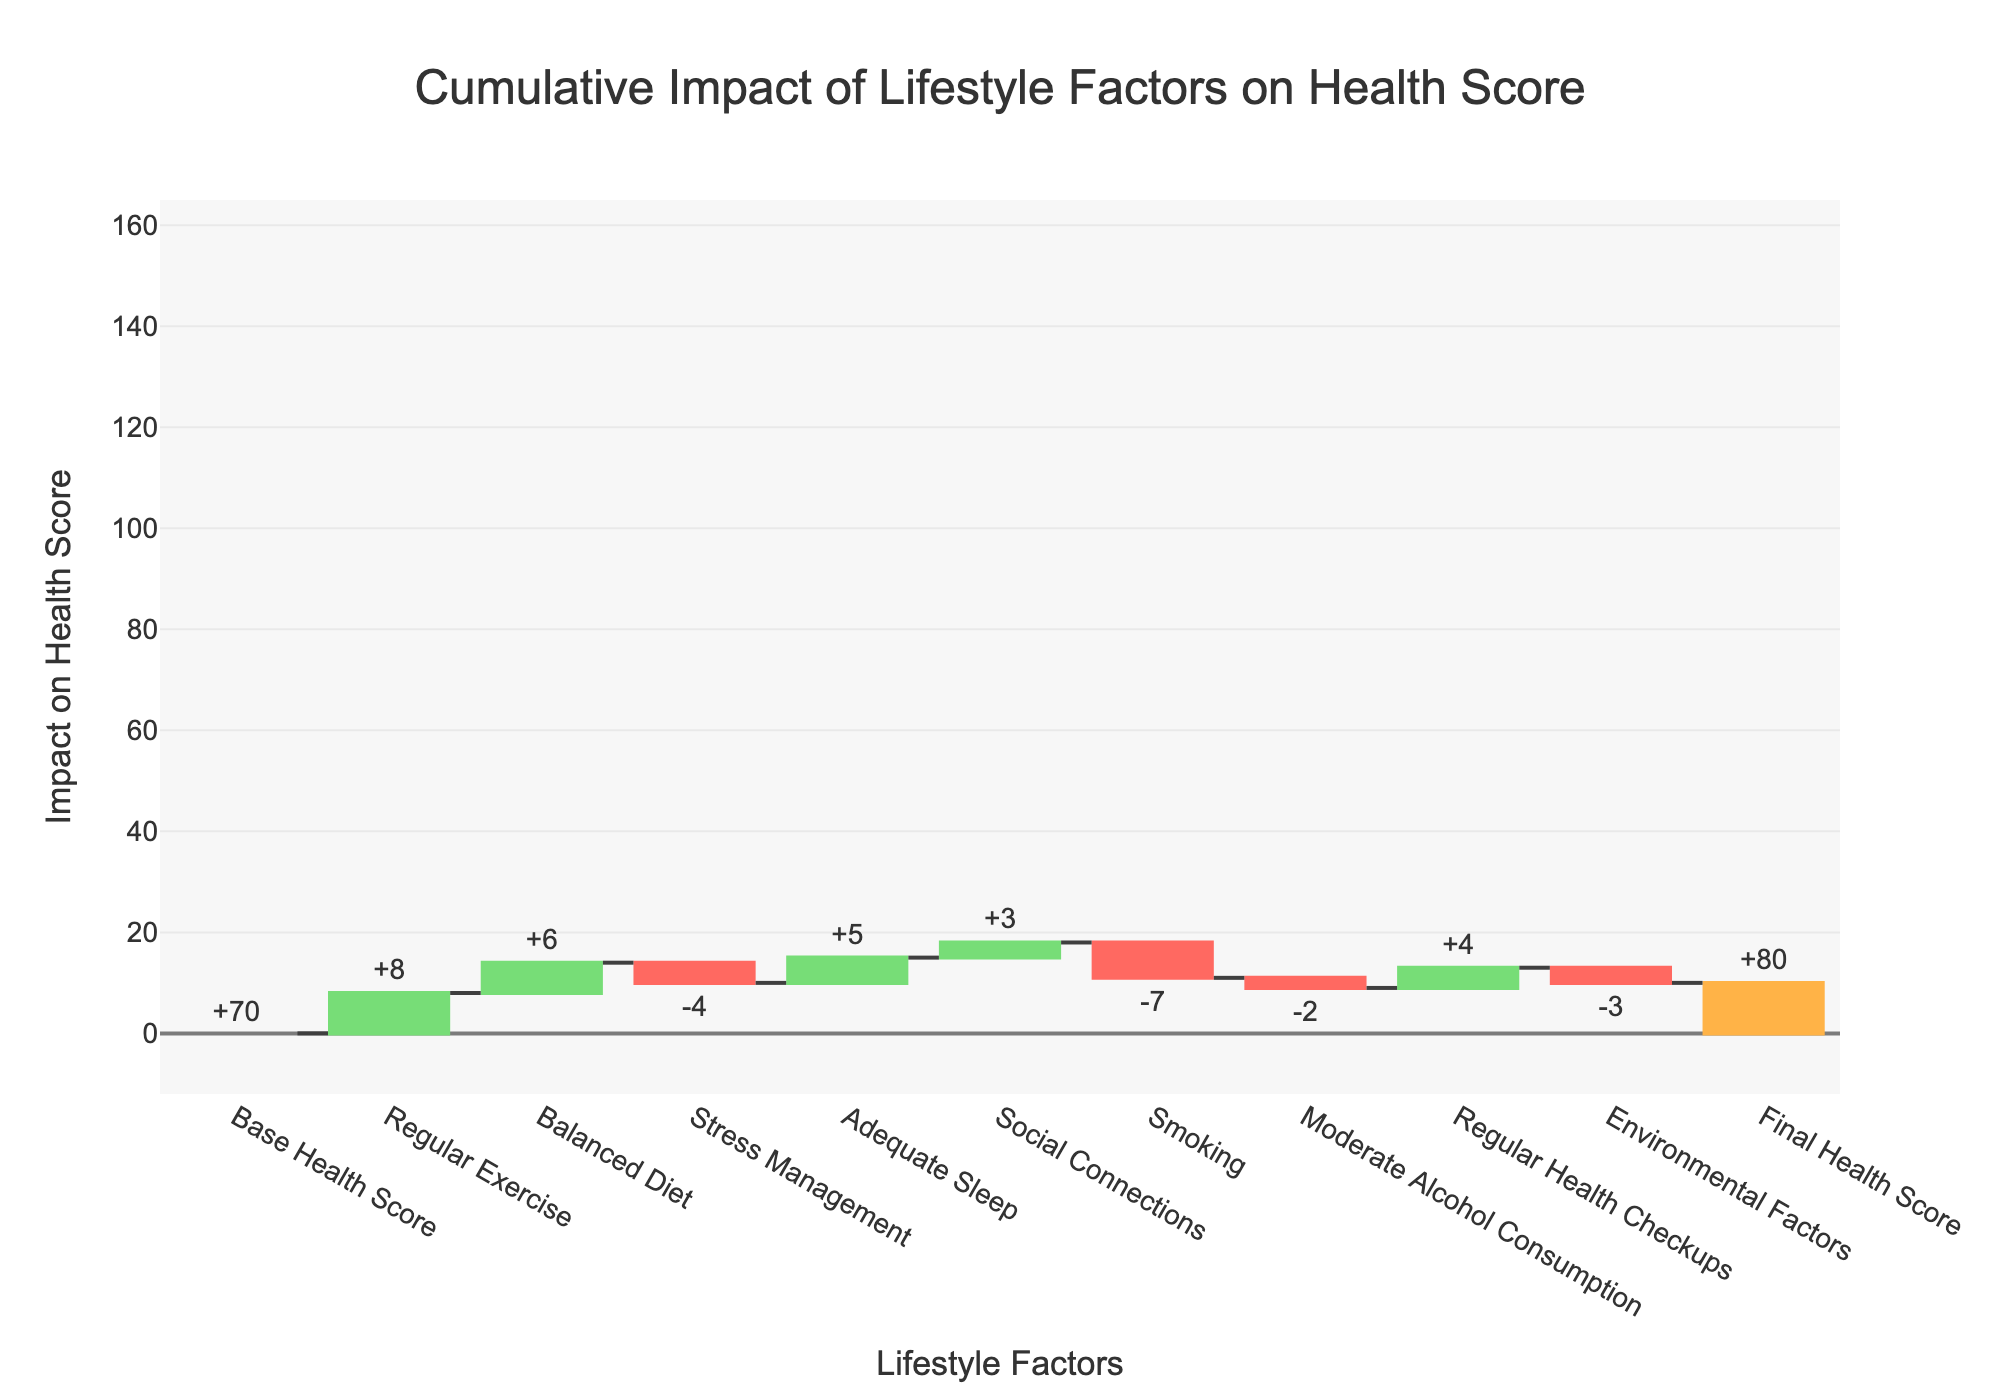How many lifestyle factors are considered in the chart? The chart includes categories for different lifestyle factors. By counting the relevant entries excluding the "Base Health Score" and "Final Health Score", we find there are 8 lifestyle factors.
Answer: 8 What is the total positive impact on the health score? Sum all the positive impacts: Regular Exercise + Balanced Diet + Adequate Sleep + Social Connections + Regular Health Checkups = +8 +6 +5 +3 +4 = +26
Answer: 26 What is the total negative impact on the health score? Sum all the negative impacts: Stress Management + Smoking + Moderate Alcohol Consumption + Environmental Factors = -4 -7 -2 -3 = -16
Answer: 16 Which lifestyle factor contributes the most negatively to the health score? Among the negative impacts, Smoking has the highest negative value at -7.
Answer: Smoking How does the final health score compare to the base health score? The base health score starts at 70. After adding and subtracting the impacts of various factors, the final health score is 80. So, the final health score is higher.
Answer: Final health score is higher What is the net impact of Regular Exercise and Balanced Diet combined? Add the impacts of Regular Exercise (+8) and Balanced Diet (+6), which gives +8 + 6 = +14.
Answer: +14 Between Stress Management and Environmental Factors, which has a smaller negative impact? Stress Management has an impact of -4 and Environmental Factors have an impact of -3. Therefore, Environmental Factors have a smaller negative impact.
Answer: Environmental Factors What is the cumulative score just before applying the impact of Smoking? Starting from the base score: 70 (Base Health Score) + 8 (Regular Exercise) + 6 (Balanced Diet) - 4 (Stress Management) + 5 (Adequate Sleep) + 3 (Social Connections) = 88.
Answer: 88 If you remove the impact of Moderate Alcohol Consumption, what would the final health score be? Without Moderate Alcohol Consumption (-2), start from the base: 70 (Base Health Score) + 8 (Regular Exercise) + 6 (Balanced Diet) - 4 (Stress Management) + 5 (Adequate Sleep) + 3 (Social Connections) - 7 (Smoking) + 4 (Regular Health Checkups) - 3 (Environmental Factors) = 82.
Answer: 82 What's the overall differential impact on health score from the contributing factors? Calculate the net effect of all factors starting from base score 70 and reaching final score 80. The overall differential is Final Score - Base Score, which is 80 - 70 = +10.
Answer: +10 